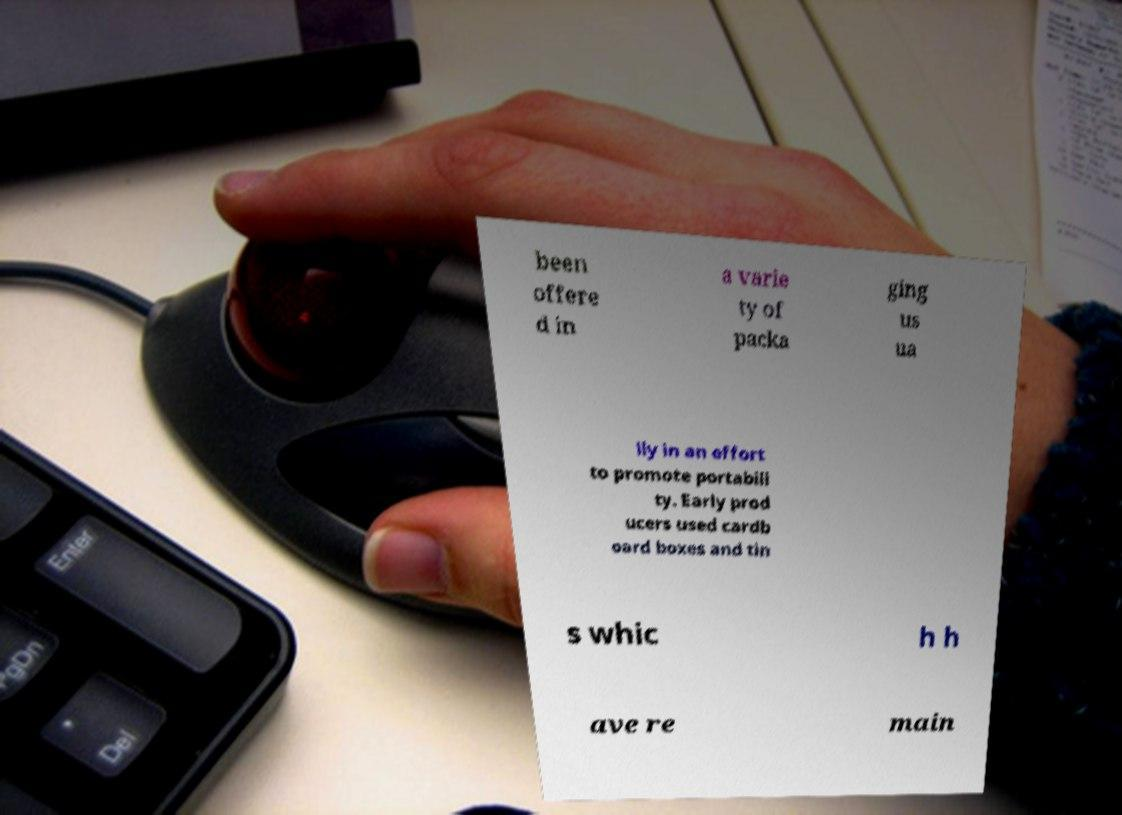Could you extract and type out the text from this image? been offere d in a varie ty of packa ging us ua lly in an effort to promote portabili ty. Early prod ucers used cardb oard boxes and tin s whic h h ave re main 